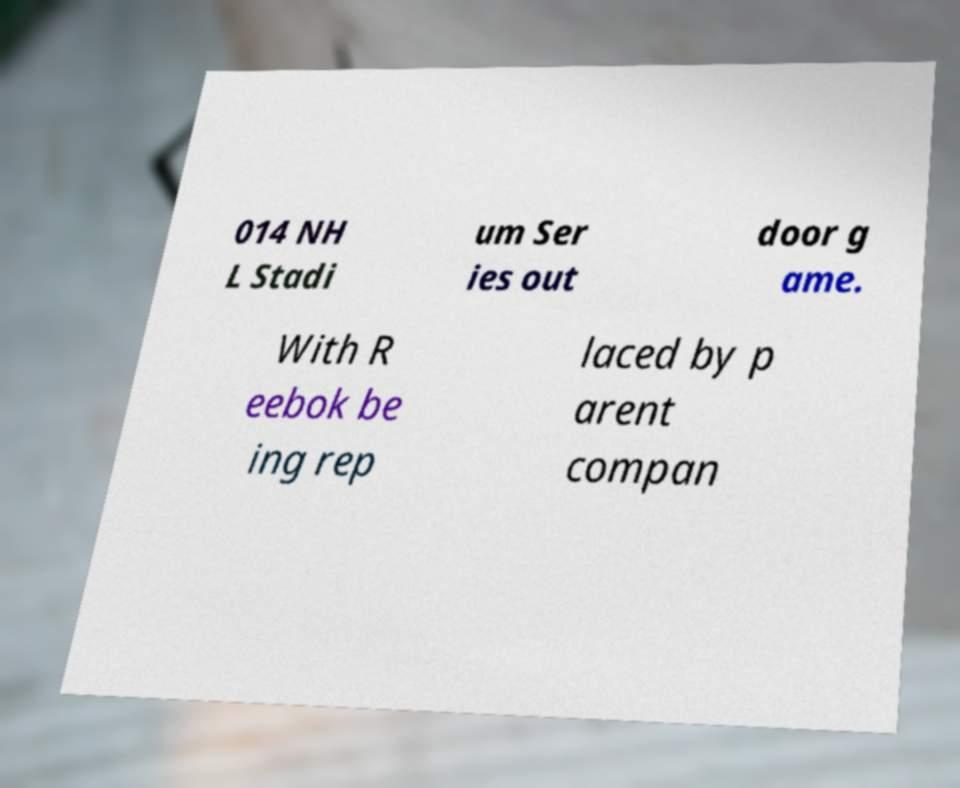Could you extract and type out the text from this image? 014 NH L Stadi um Ser ies out door g ame. With R eebok be ing rep laced by p arent compan 